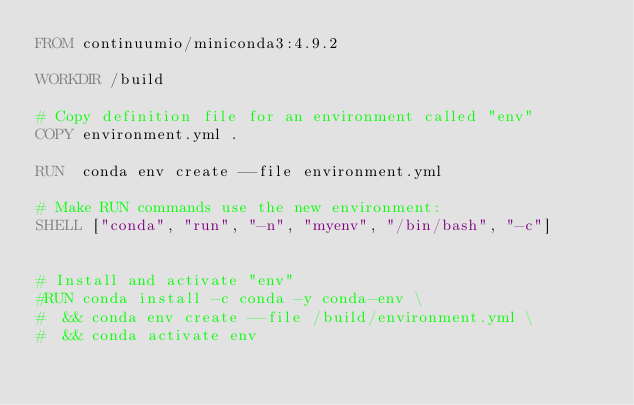Convert code to text. <code><loc_0><loc_0><loc_500><loc_500><_Dockerfile_>FROM continuumio/miniconda3:4.9.2

WORKDIR /build

# Copy definition file for an environment called "env"
COPY environment.yml .

RUN  conda env create --file environment.yml 

# Make RUN commands use the new environment:
SHELL ["conda", "run", "-n", "myenv", "/bin/bash", "-c"]


# Install and activate "env"
#RUN conda install -c conda -y conda-env \
#  && conda env create --file /build/environment.yml \
#  && conda activate env 
</code> 